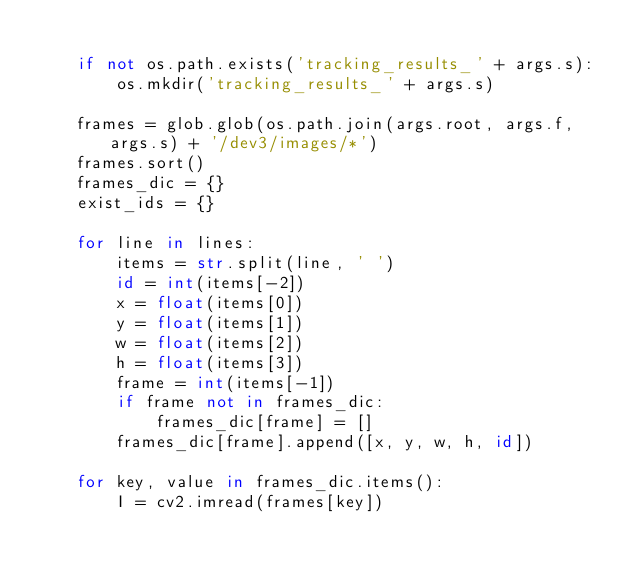<code> <loc_0><loc_0><loc_500><loc_500><_Python_>
    if not os.path.exists('tracking_results_' + args.s):
        os.mkdir('tracking_results_' + args.s)

    frames = glob.glob(os.path.join(args.root, args.f, args.s) + '/dev3/images/*')
    frames.sort()
    frames_dic = {}
    exist_ids = {}

    for line in lines:
        items = str.split(line, ' ')
        id = int(items[-2])
        x = float(items[0])
        y = float(items[1])
        w = float(items[2])
        h = float(items[3])
        frame = int(items[-1])
        if frame not in frames_dic:
            frames_dic[frame] = []
        frames_dic[frame].append([x, y, w, h, id])

    for key, value in frames_dic.items():
        I = cv2.imread(frames[key])</code> 